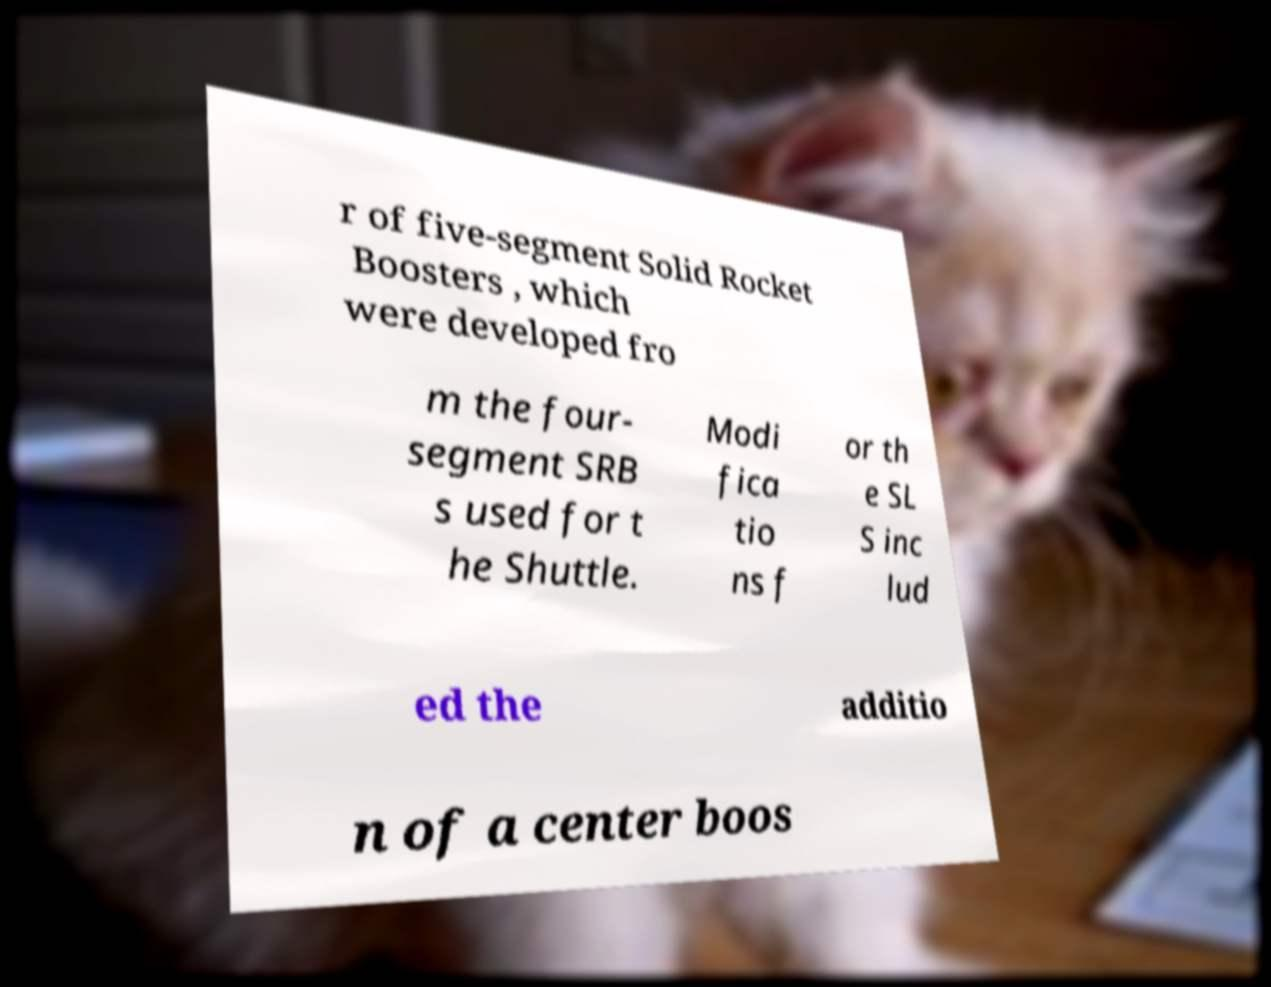What messages or text are displayed in this image? I need them in a readable, typed format. r of five-segment Solid Rocket Boosters , which were developed fro m the four- segment SRB s used for t he Shuttle. Modi fica tio ns f or th e SL S inc lud ed the additio n of a center boos 